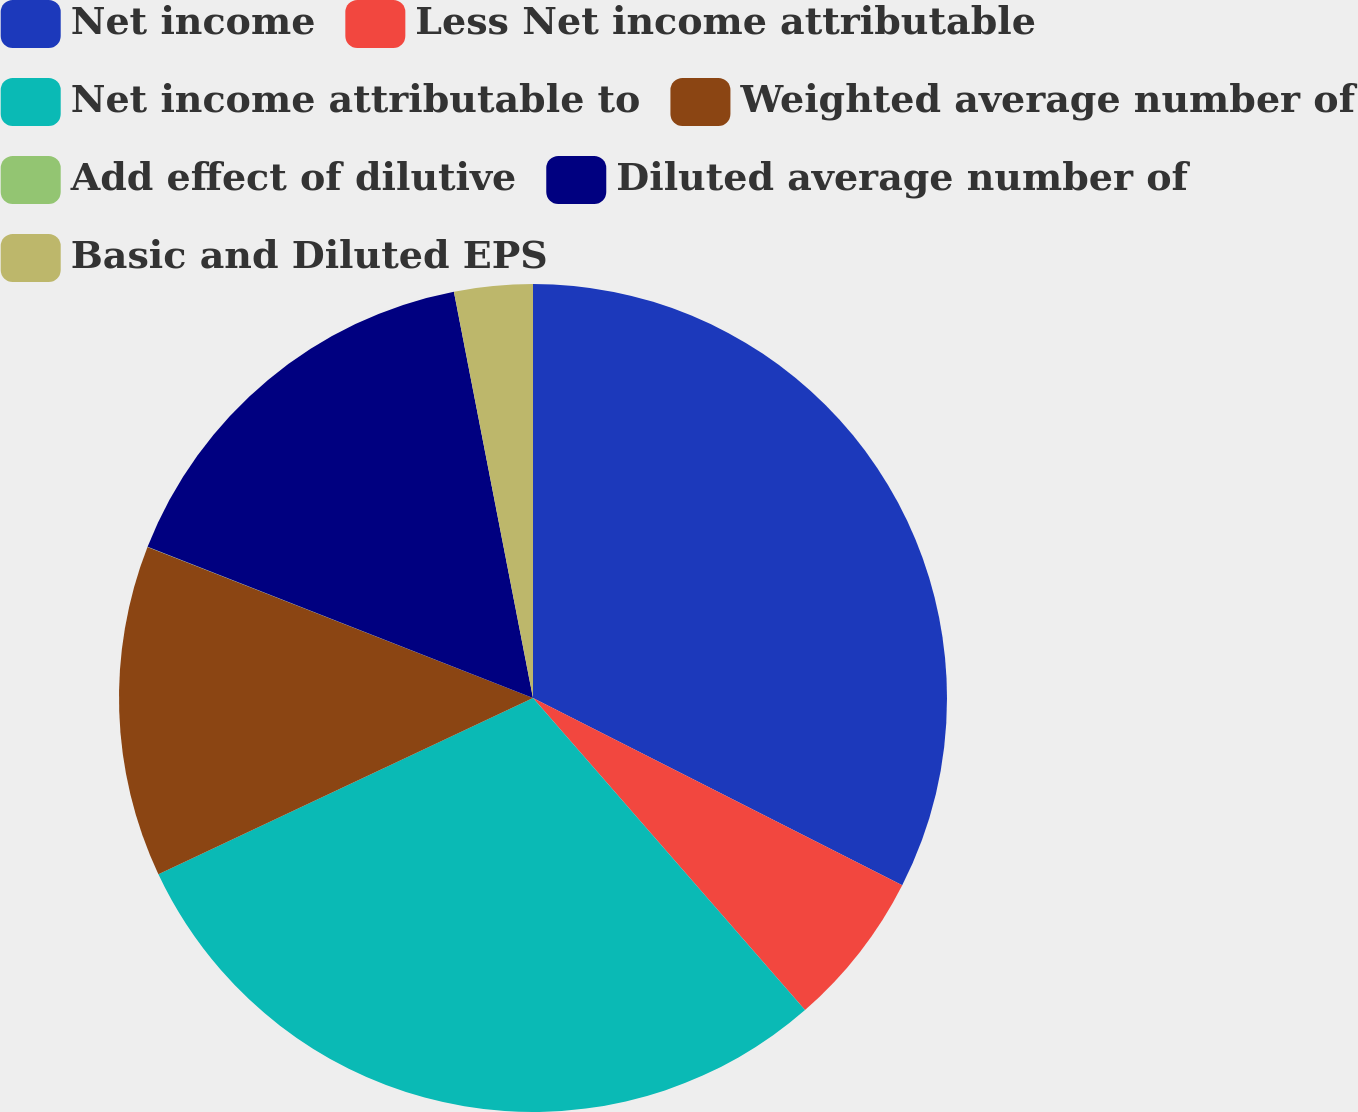<chart> <loc_0><loc_0><loc_500><loc_500><pie_chart><fcel>Net income<fcel>Less Net income attributable<fcel>Net income attributable to<fcel>Weighted average number of<fcel>Add effect of dilutive<fcel>Diluted average number of<fcel>Basic and Diluted EPS<nl><fcel>32.47%<fcel>6.12%<fcel>29.41%<fcel>12.94%<fcel>0.01%<fcel>15.99%<fcel>3.06%<nl></chart> 